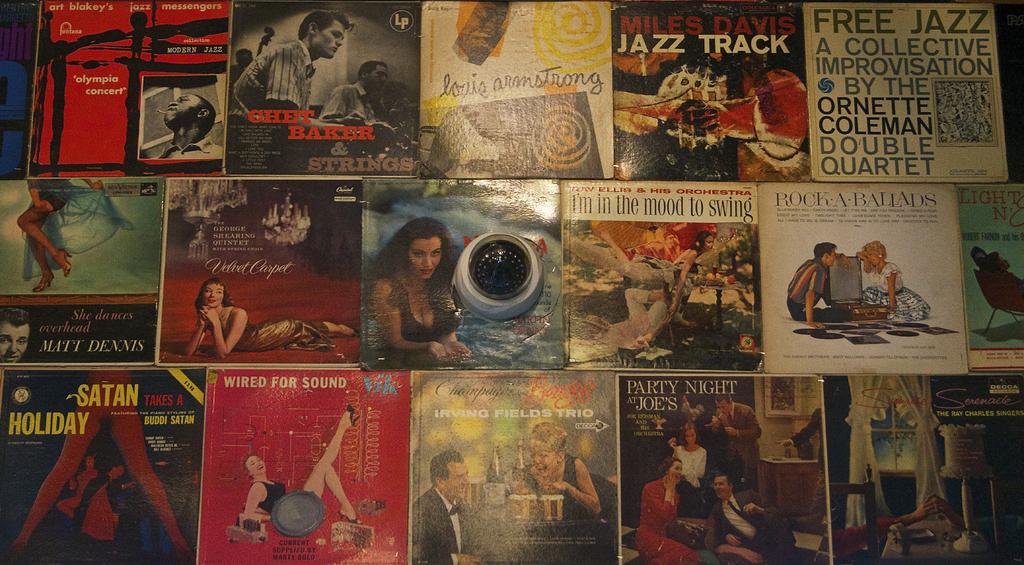Who performs the jazz track album?
Your answer should be very brief. Miles davis. Name one of the singers?
Your answer should be very brief. Miles davis. 